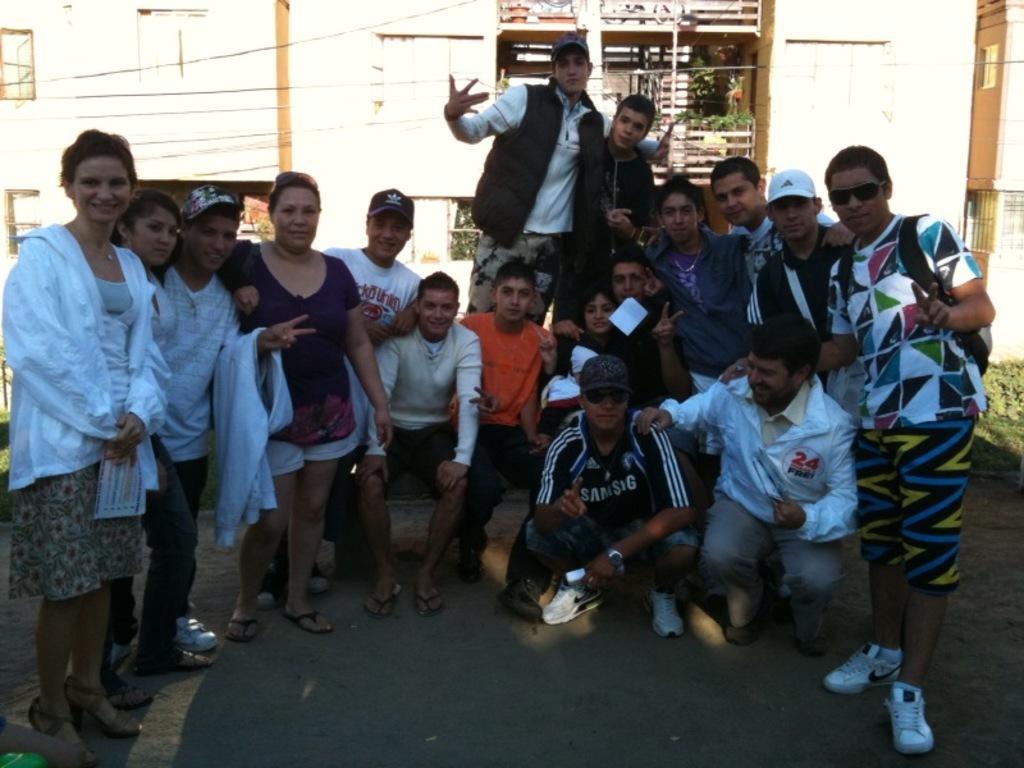Please provide a concise description of this image. In this image there are group of people some of them are standing, and some of them are sitting on their knees. At the bottom there is walkway and in the background there are some houses, poles, wires and some plants. 